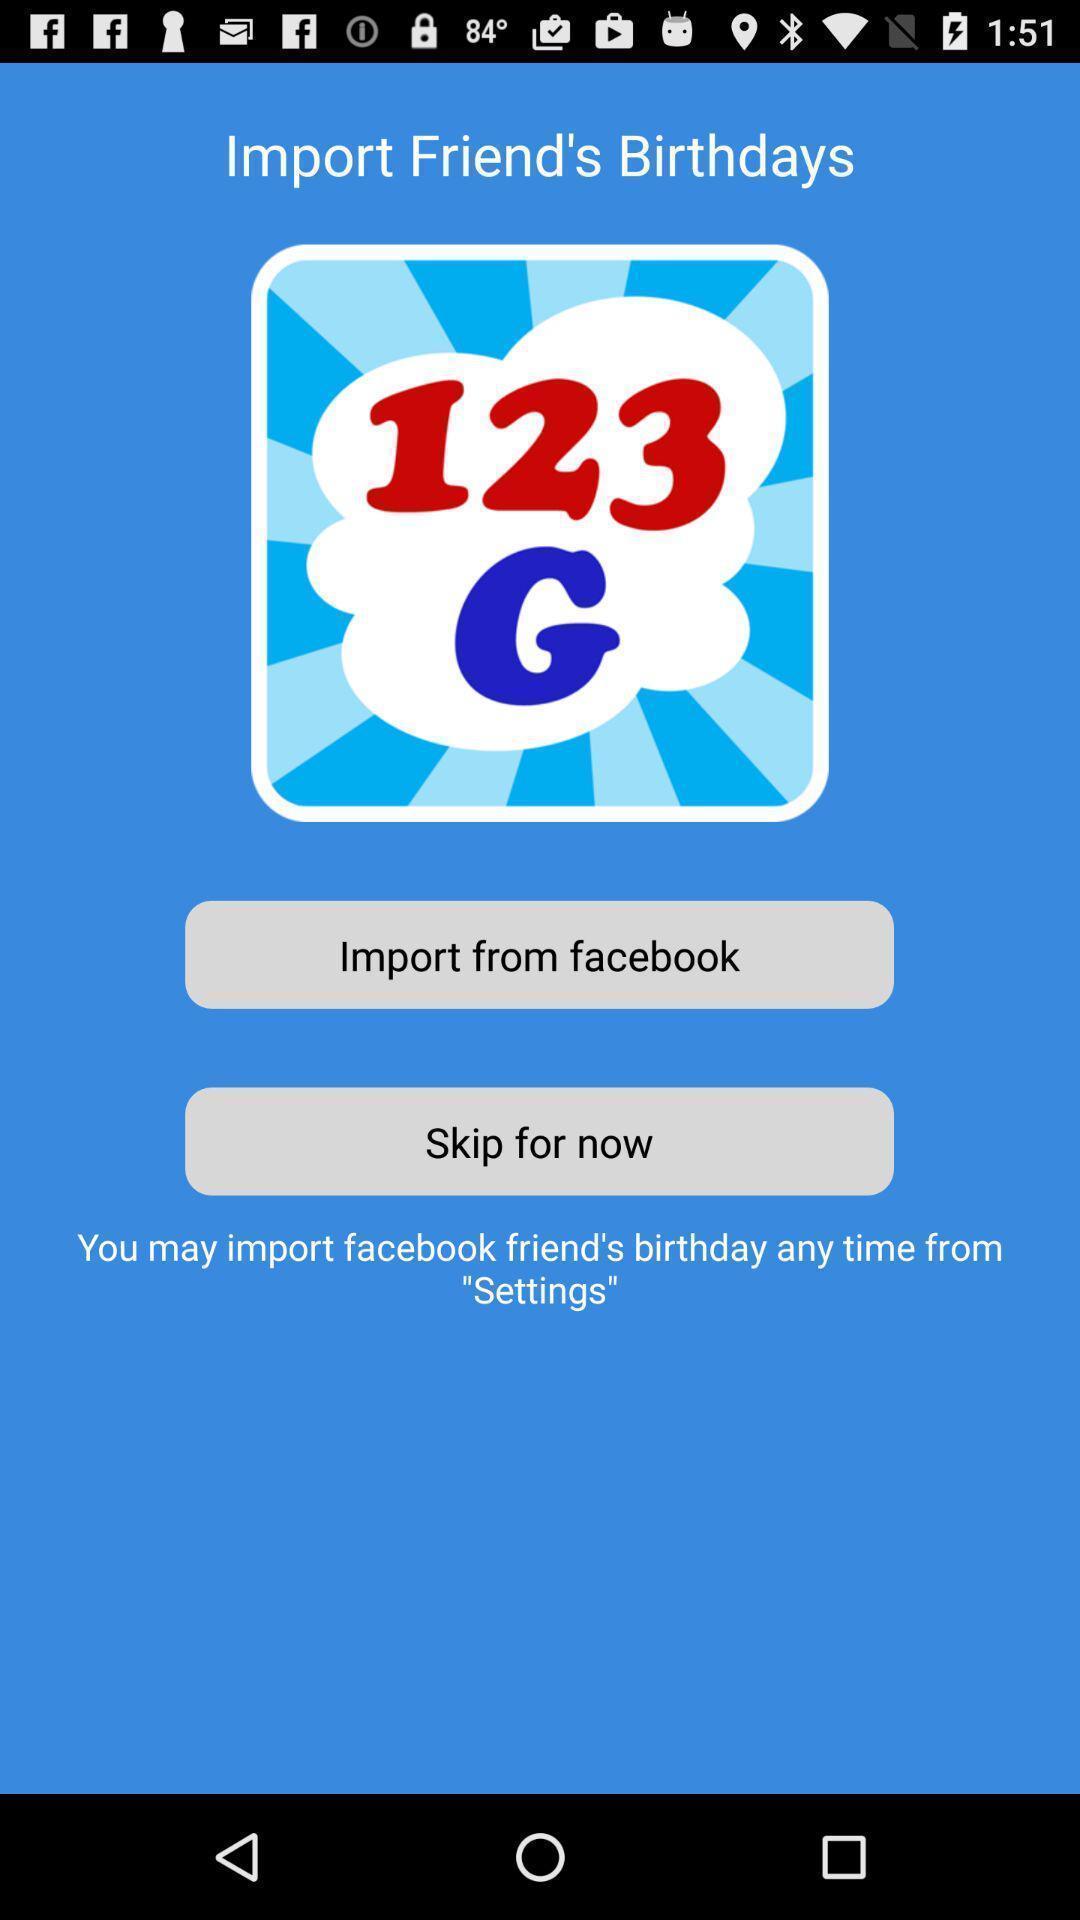What can you discern from this picture? Page displaying to import birthdays in app. 